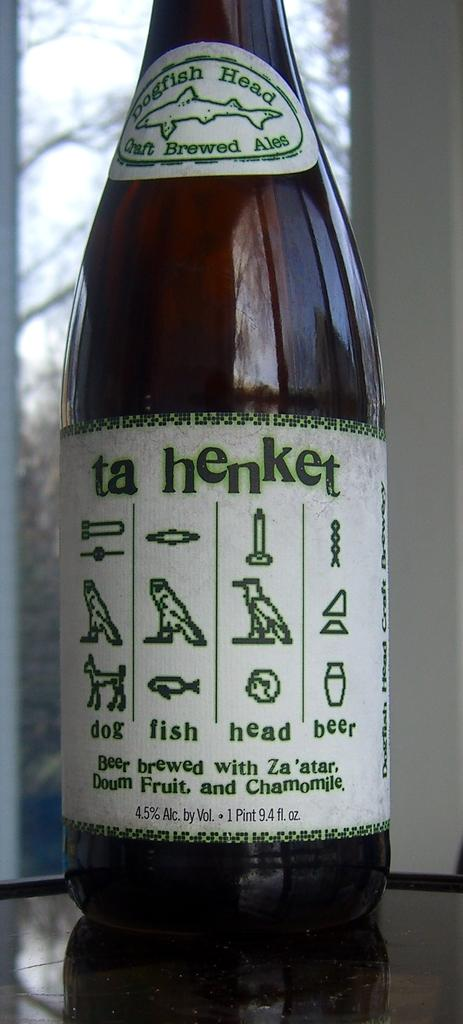Provide a one-sentence caption for the provided image. A bottle of Ta Hebket feature Egyptian Heiroglyphs. 